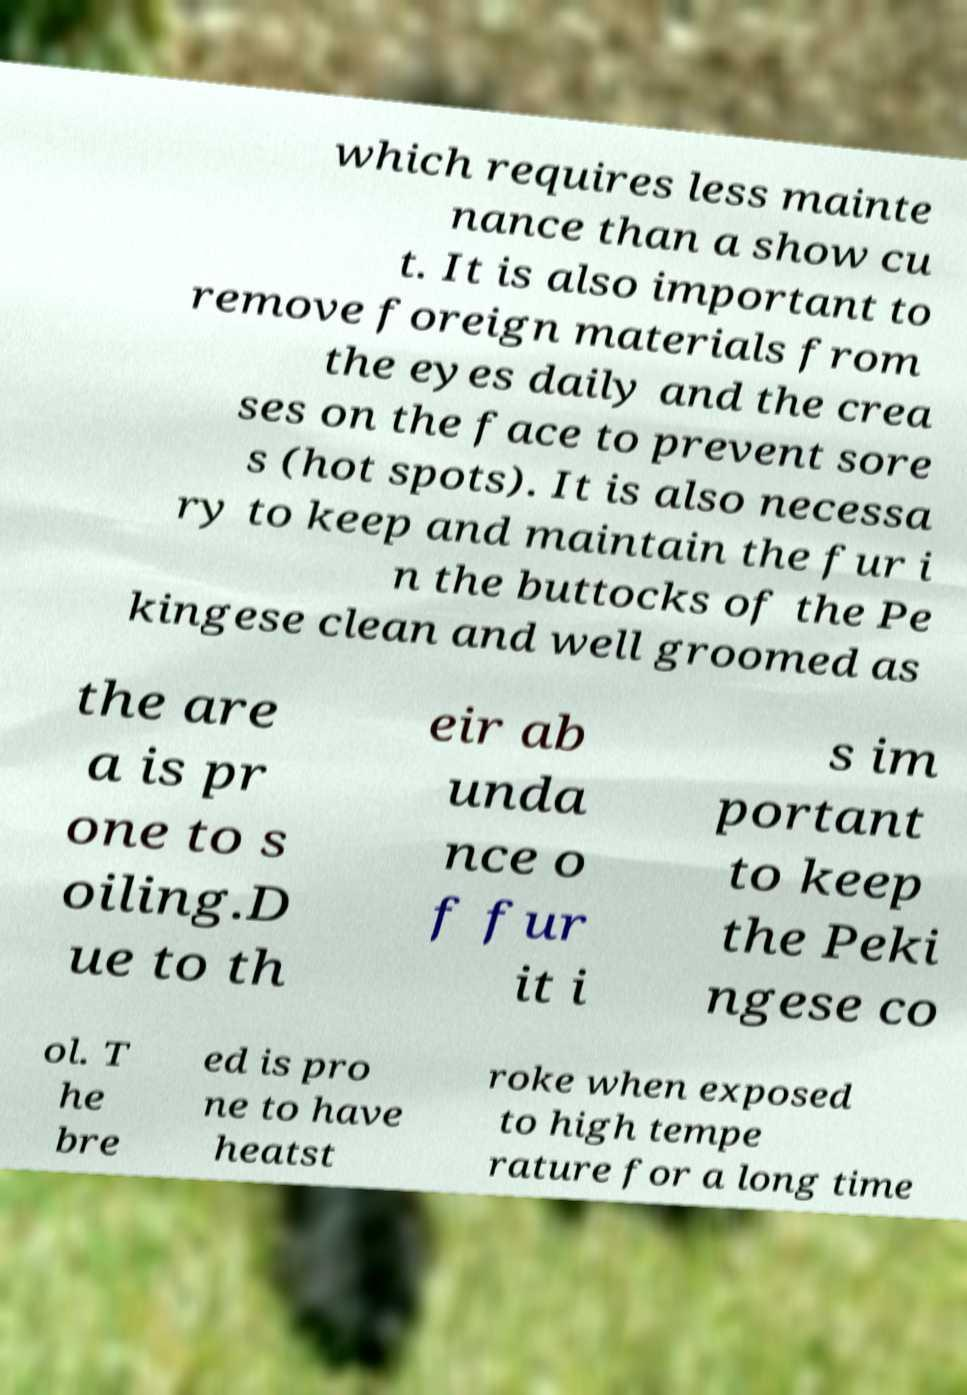Can you accurately transcribe the text from the provided image for me? which requires less mainte nance than a show cu t. It is also important to remove foreign materials from the eyes daily and the crea ses on the face to prevent sore s (hot spots). It is also necessa ry to keep and maintain the fur i n the buttocks of the Pe kingese clean and well groomed as the are a is pr one to s oiling.D ue to th eir ab unda nce o f fur it i s im portant to keep the Peki ngese co ol. T he bre ed is pro ne to have heatst roke when exposed to high tempe rature for a long time 